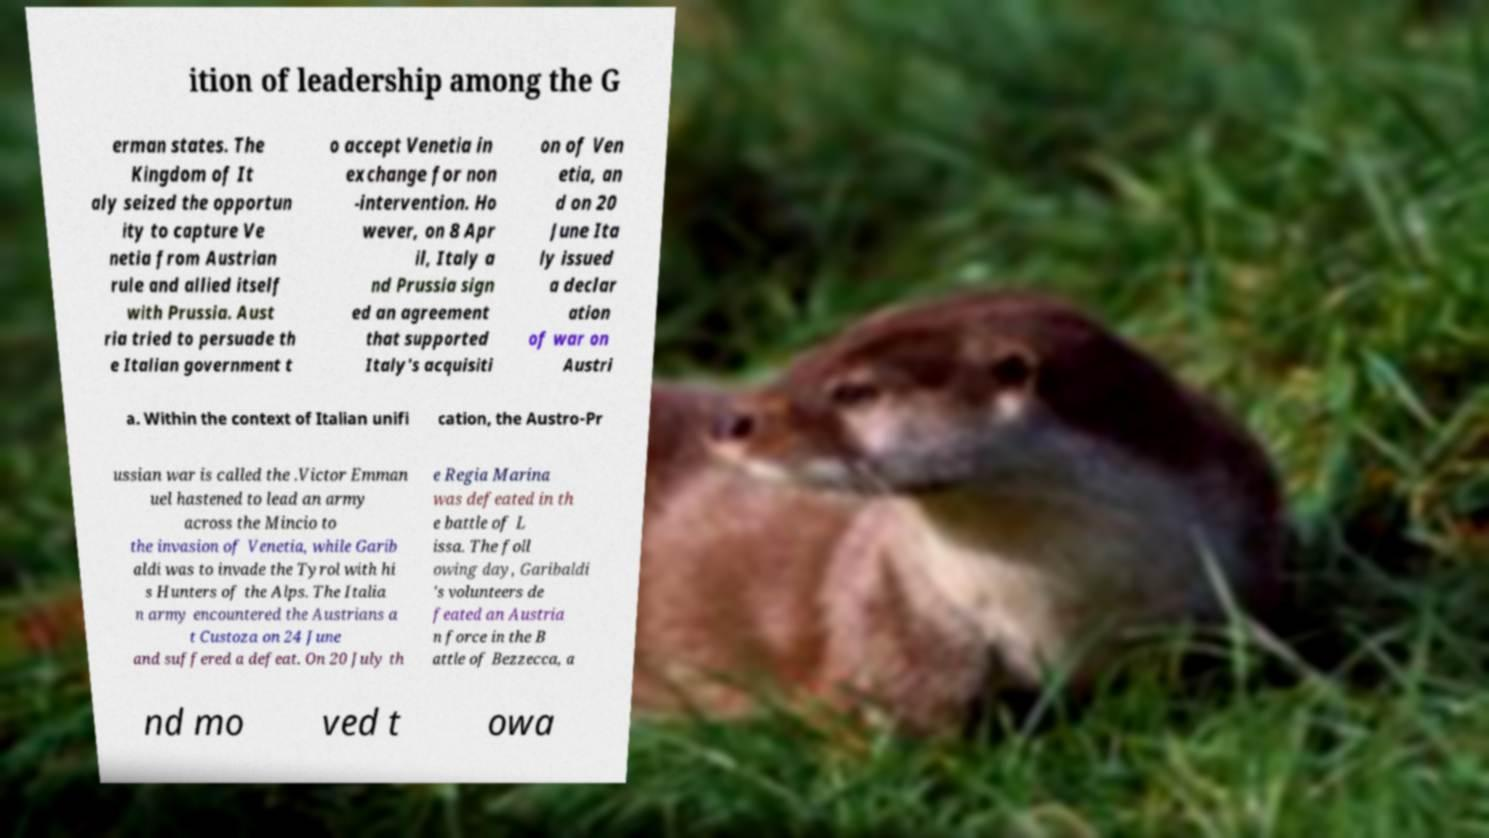For documentation purposes, I need the text within this image transcribed. Could you provide that? ition of leadership among the G erman states. The Kingdom of It aly seized the opportun ity to capture Ve netia from Austrian rule and allied itself with Prussia. Aust ria tried to persuade th e Italian government t o accept Venetia in exchange for non -intervention. Ho wever, on 8 Apr il, Italy a nd Prussia sign ed an agreement that supported Italy's acquisiti on of Ven etia, an d on 20 June Ita ly issued a declar ation of war on Austri a. Within the context of Italian unifi cation, the Austro-Pr ussian war is called the .Victor Emman uel hastened to lead an army across the Mincio to the invasion of Venetia, while Garib aldi was to invade the Tyrol with hi s Hunters of the Alps. The Italia n army encountered the Austrians a t Custoza on 24 June and suffered a defeat. On 20 July th e Regia Marina was defeated in th e battle of L issa. The foll owing day, Garibaldi 's volunteers de feated an Austria n force in the B attle of Bezzecca, a nd mo ved t owa 